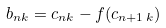<formula> <loc_0><loc_0><loc_500><loc_500>b _ { n k } = c _ { n k } - f ( c _ { n + 1 \, k } )</formula> 